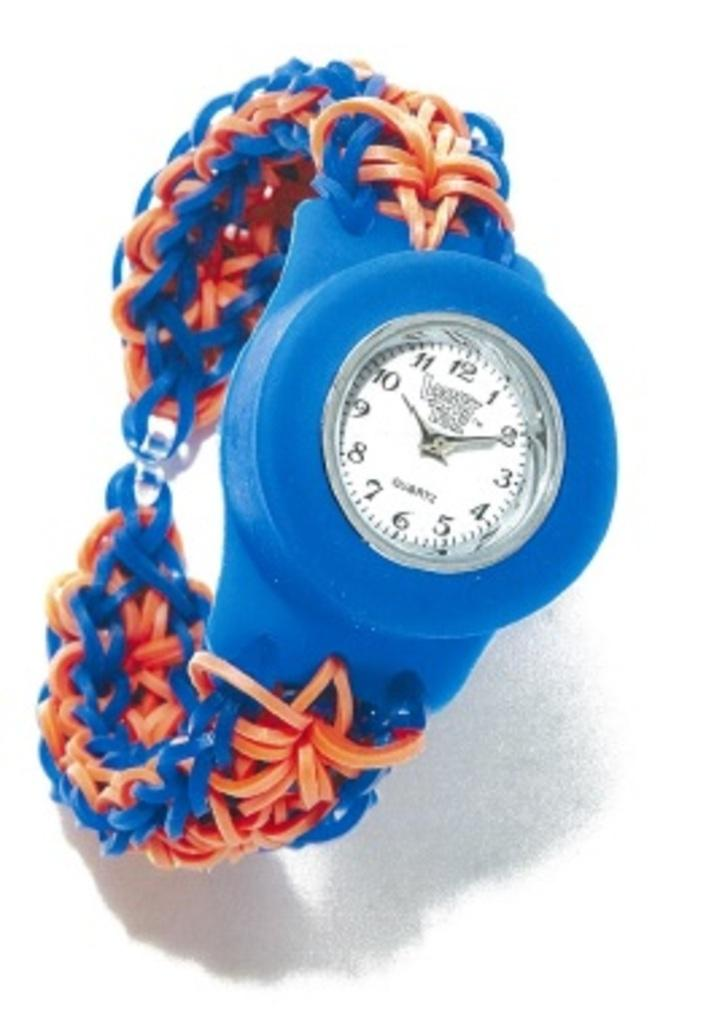<image>
Provide a brief description of the given image. A blue wristwatch currently showing the time of 10:10. 